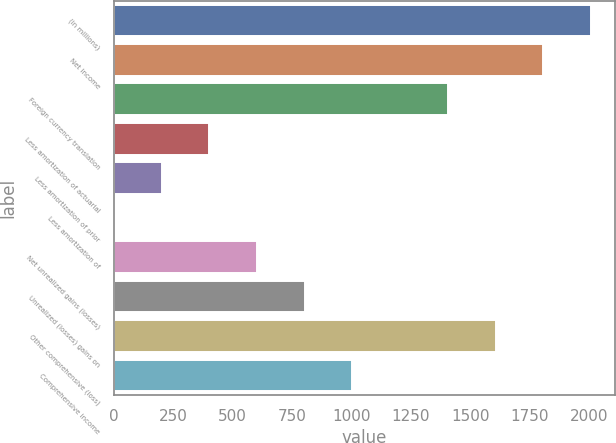Convert chart. <chart><loc_0><loc_0><loc_500><loc_500><bar_chart><fcel>(in millions)<fcel>Net income<fcel>Foreign currency translation<fcel>Less amortization of actuarial<fcel>Less amortization of prior<fcel>Less amortization of<fcel>Net unrealized gains (losses)<fcel>Unrealized (losses) gains on<fcel>Other comprehensive (loss)<fcel>Comprehensive income<nl><fcel>2008<fcel>1807.21<fcel>1405.63<fcel>401.68<fcel>200.89<fcel>0.1<fcel>602.47<fcel>803.26<fcel>1606.42<fcel>1004.05<nl></chart> 